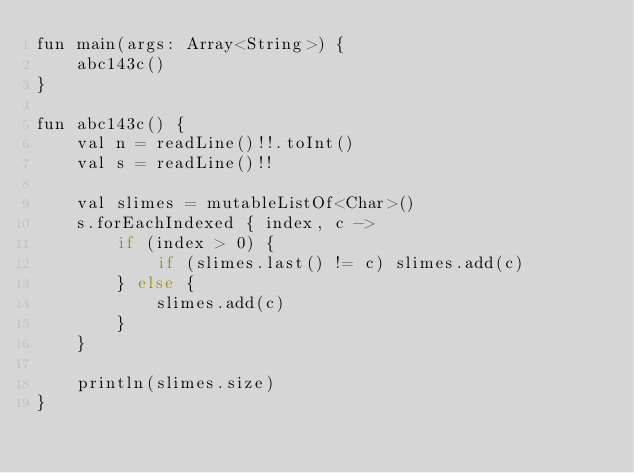<code> <loc_0><loc_0><loc_500><loc_500><_Java_>fun main(args: Array<String>) {
    abc143c()
}

fun abc143c() {
    val n = readLine()!!.toInt()
    val s = readLine()!!

    val slimes = mutableListOf<Char>()
    s.forEachIndexed { index, c ->
        if (index > 0) {
            if (slimes.last() != c) slimes.add(c)
        } else {
            slimes.add(c)
        }
    }

    println(slimes.size)
}
</code> 